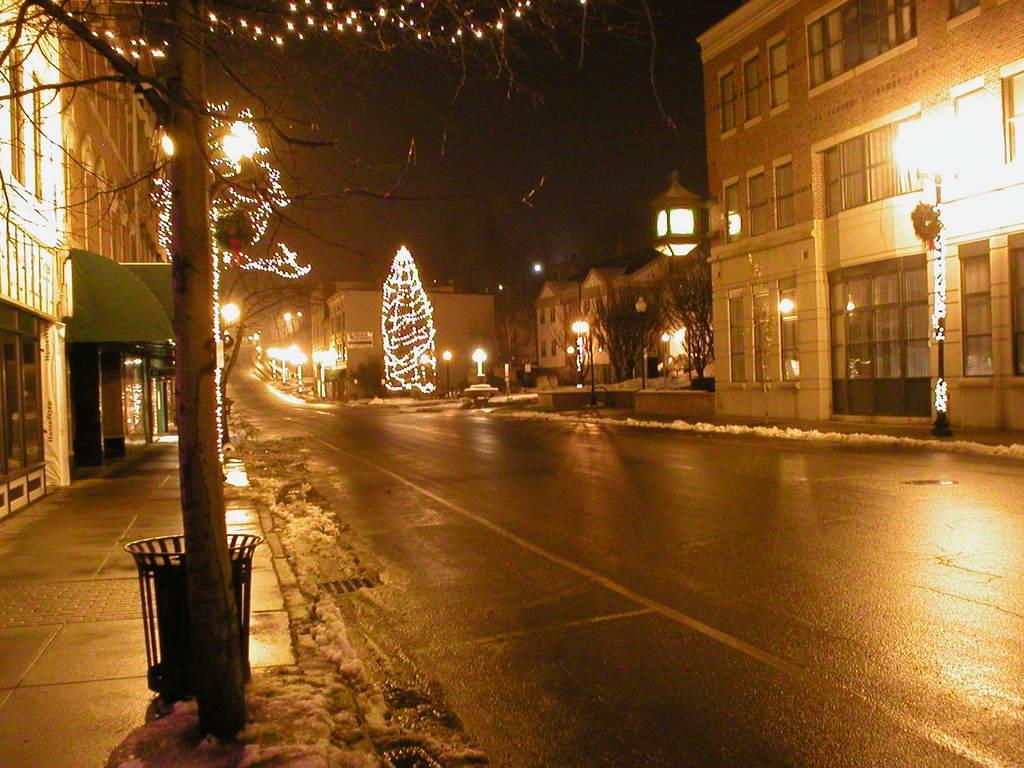In one or two sentences, can you explain what this image depicts? In this picture we can see few buildings, trees, poles and lights, on the left side of the image we can see a dustbin. 